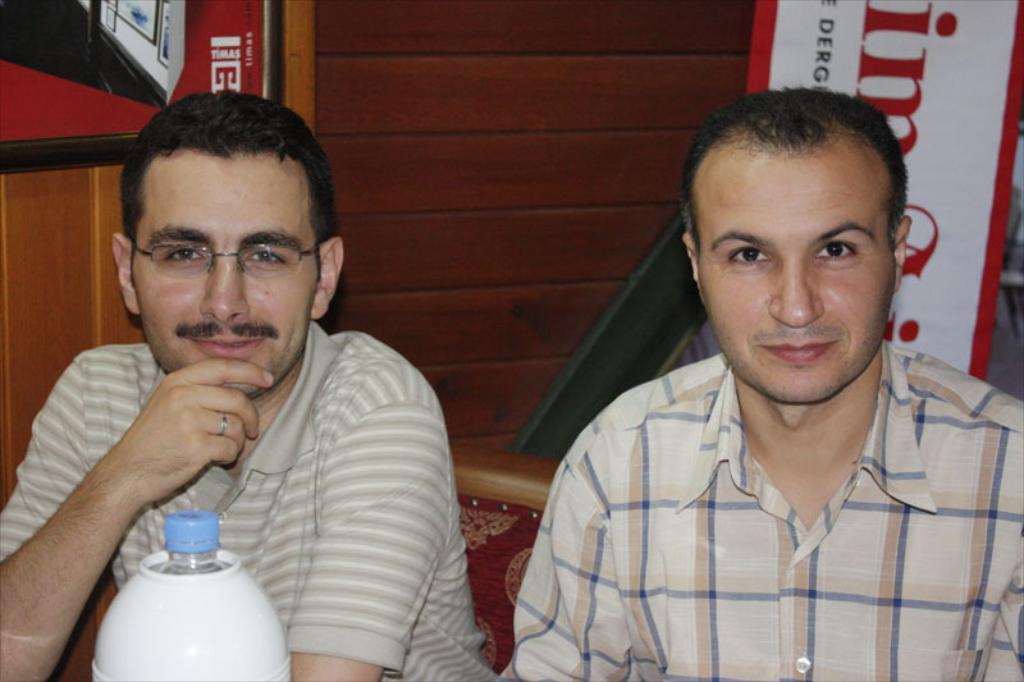How many people are in the image? There are two persons in the image. What are the persons doing in the image? The persons are sitting on chairs. Can you describe one of the persons in the image? One of the persons is wearing spectacles. What object can be seen in the image besides the persons and chairs? There is a bottle visible in the image. What type of duck can be seen in the image? There is no duck present in the image. How does the bottle begin to burn in the image? The bottle does not begin to burn in the image; there is no indication of fire or heat. 